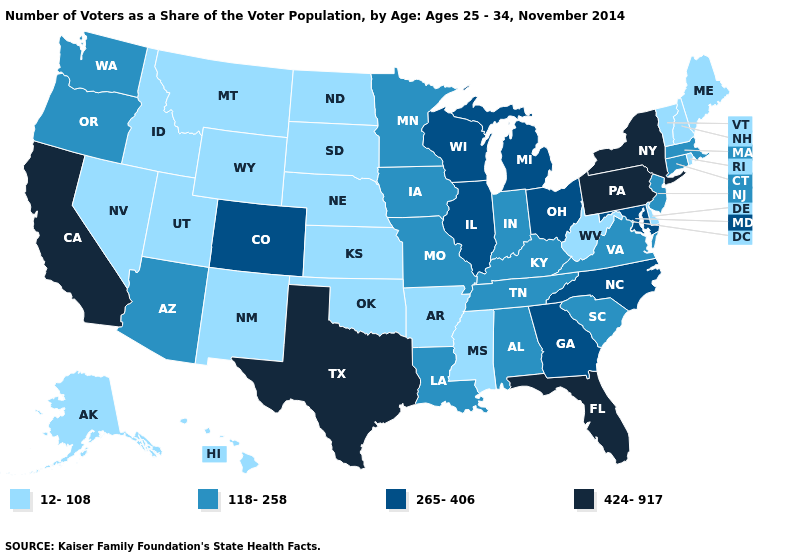Among the states that border Nebraska , which have the lowest value?
Write a very short answer. Kansas, South Dakota, Wyoming. Which states have the lowest value in the West?
Short answer required. Alaska, Hawaii, Idaho, Montana, Nevada, New Mexico, Utah, Wyoming. Does Utah have a lower value than Florida?
Concise answer only. Yes. What is the highest value in the USA?
Write a very short answer. 424-917. What is the value of Mississippi?
Answer briefly. 12-108. Does Wisconsin have the same value as Rhode Island?
Short answer required. No. What is the value of Oregon?
Concise answer only. 118-258. Among the states that border Kentucky , which have the highest value?
Give a very brief answer. Illinois, Ohio. What is the value of Georgia?
Be succinct. 265-406. What is the value of Wisconsin?
Answer briefly. 265-406. What is the highest value in the USA?
Concise answer only. 424-917. Name the states that have a value in the range 12-108?
Quick response, please. Alaska, Arkansas, Delaware, Hawaii, Idaho, Kansas, Maine, Mississippi, Montana, Nebraska, Nevada, New Hampshire, New Mexico, North Dakota, Oklahoma, Rhode Island, South Dakota, Utah, Vermont, West Virginia, Wyoming. Does the map have missing data?
Quick response, please. No. Among the states that border Arizona , which have the highest value?
Write a very short answer. California. Among the states that border Missouri , does Illinois have the highest value?
Keep it brief. Yes. 